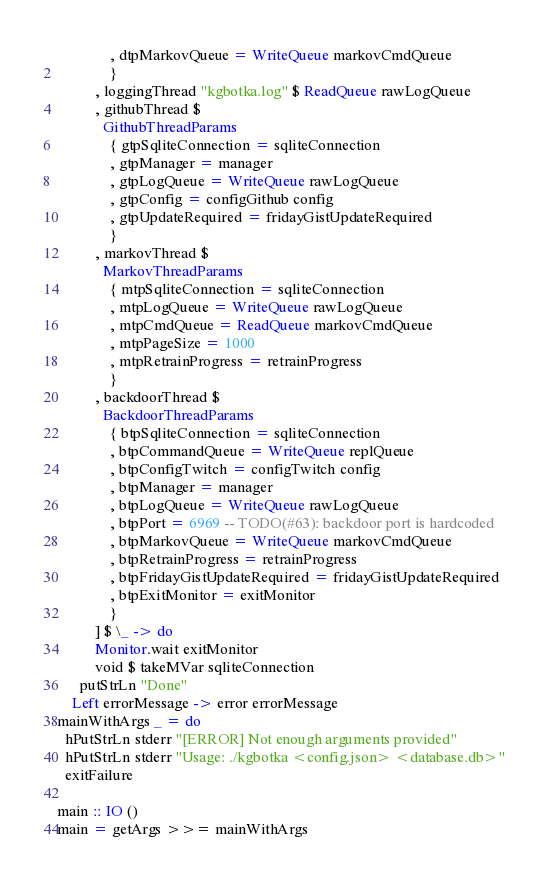<code> <loc_0><loc_0><loc_500><loc_500><_Haskell_>              , dtpMarkovQueue = WriteQueue markovCmdQueue
              }
          , loggingThread "kgbotka.log" $ ReadQueue rawLogQueue
          , githubThread $
            GithubThreadParams
              { gtpSqliteConnection = sqliteConnection
              , gtpManager = manager
              , gtpLogQueue = WriteQueue rawLogQueue
              , gtpConfig = configGithub config
              , gtpUpdateRequired = fridayGistUpdateRequired
              }
          , markovThread $
            MarkovThreadParams
              { mtpSqliteConnection = sqliteConnection
              , mtpLogQueue = WriteQueue rawLogQueue
              , mtpCmdQueue = ReadQueue markovCmdQueue
              , mtpPageSize = 1000
              , mtpRetrainProgress = retrainProgress
              }
          , backdoorThread $
            BackdoorThreadParams
              { btpSqliteConnection = sqliteConnection
              , btpCommandQueue = WriteQueue replQueue
              , btpConfigTwitch = configTwitch config
              , btpManager = manager
              , btpLogQueue = WriteQueue rawLogQueue
              , btpPort = 6969 -- TODO(#63): backdoor port is hardcoded
              , btpMarkovQueue = WriteQueue markovCmdQueue
              , btpRetrainProgress = retrainProgress
              , btpFridayGistUpdateRequired = fridayGistUpdateRequired
              , btpExitMonitor = exitMonitor
              }
          ] $ \_ -> do
          Monitor.wait exitMonitor
          void $ takeMVar sqliteConnection
      putStrLn "Done"
    Left errorMessage -> error errorMessage
mainWithArgs _ = do
  hPutStrLn stderr "[ERROR] Not enough arguments provided"
  hPutStrLn stderr "Usage: ./kgbotka <config.json> <database.db>"
  exitFailure

main :: IO ()
main = getArgs >>= mainWithArgs
</code> 